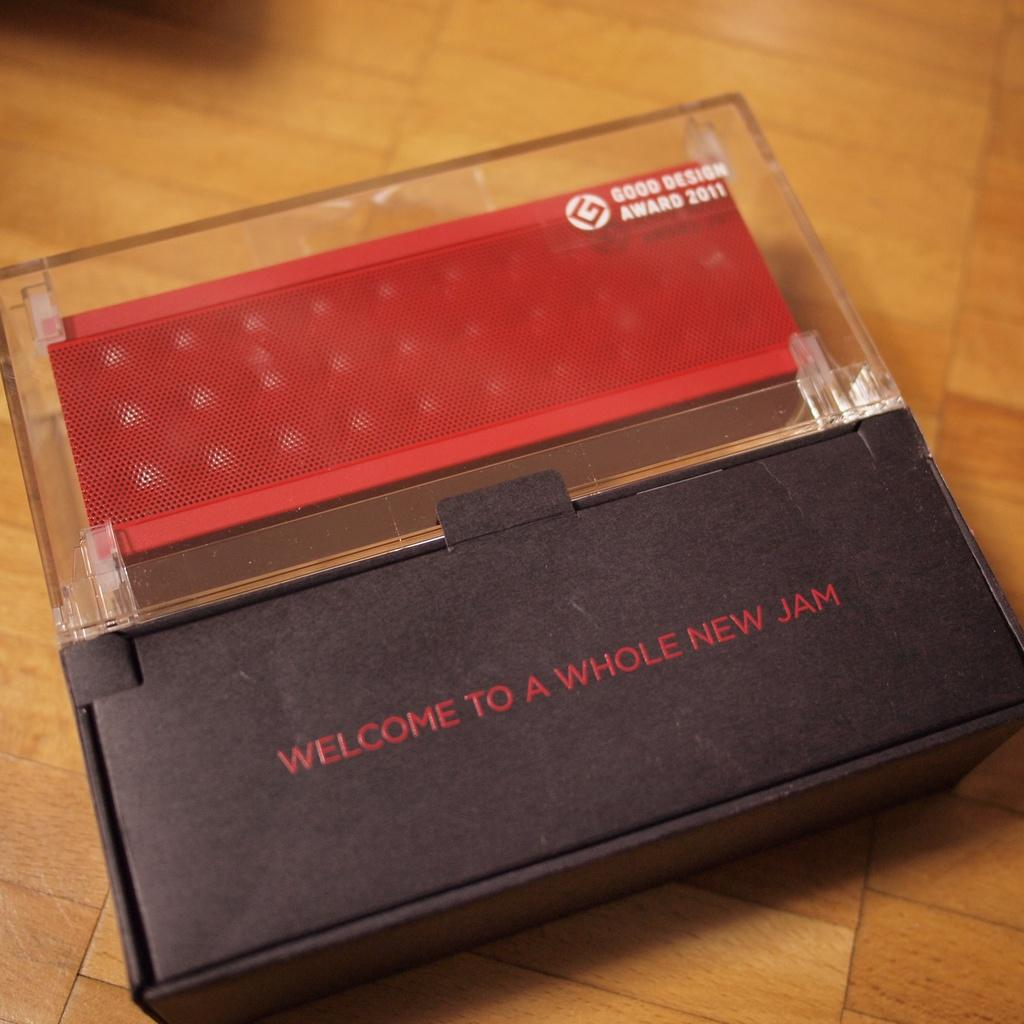Provide a one-sentence caption for the provided image. Wireless speaker that received the Good Design award in 2011. 